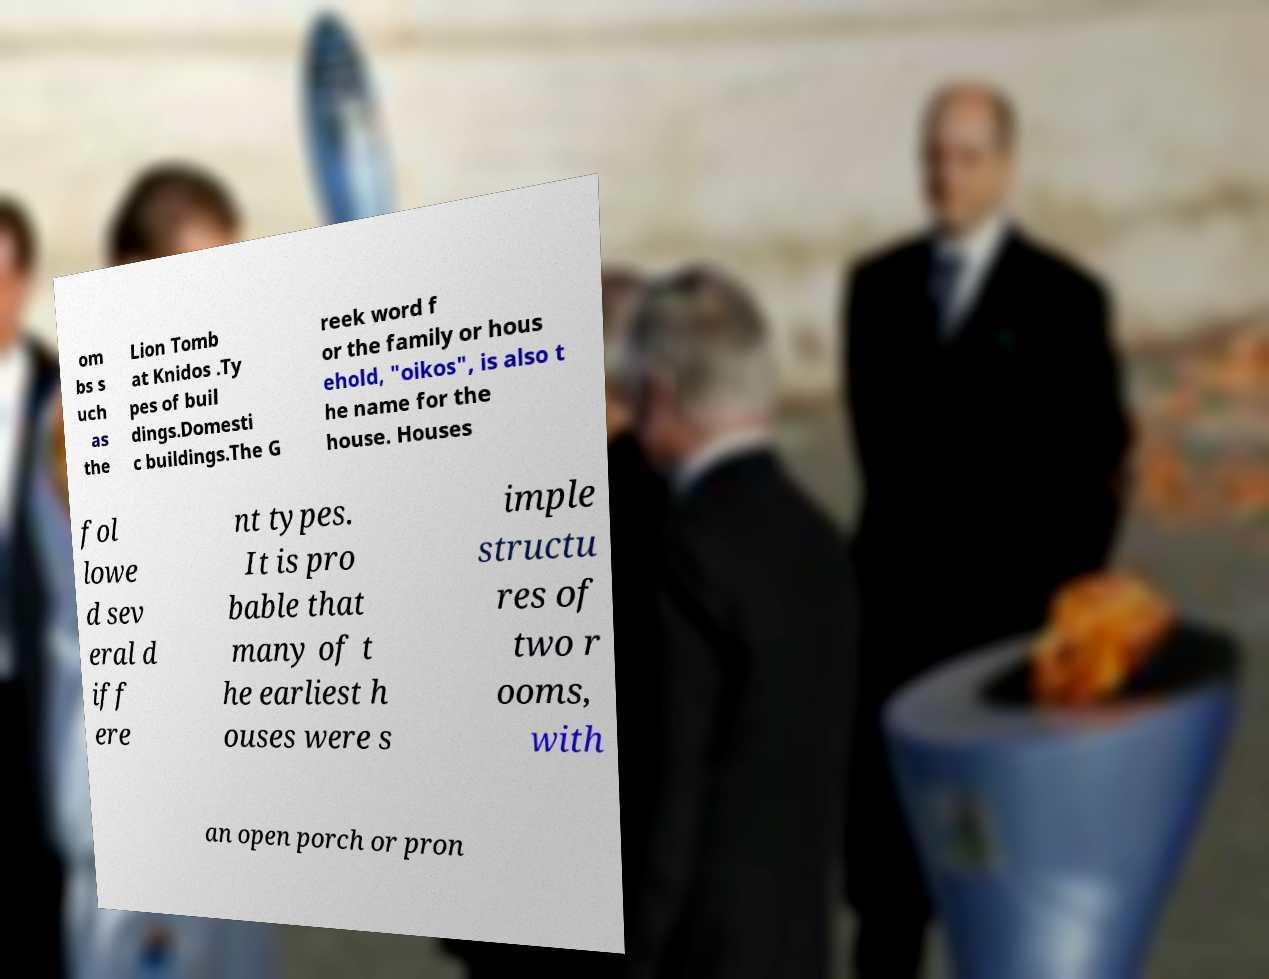Can you accurately transcribe the text from the provided image for me? om bs s uch as the Lion Tomb at Knidos .Ty pes of buil dings.Domesti c buildings.The G reek word f or the family or hous ehold, "oikos", is also t he name for the house. Houses fol lowe d sev eral d iff ere nt types. It is pro bable that many of t he earliest h ouses were s imple structu res of two r ooms, with an open porch or pron 